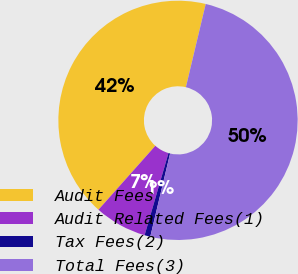Convert chart. <chart><loc_0><loc_0><loc_500><loc_500><pie_chart><fcel>Audit Fees<fcel>Audit Related Fees(1)<fcel>Tax Fees(2)<fcel>Total Fees(3)<nl><fcel>42.15%<fcel>7.07%<fcel>0.78%<fcel>50.0%<nl></chart> 